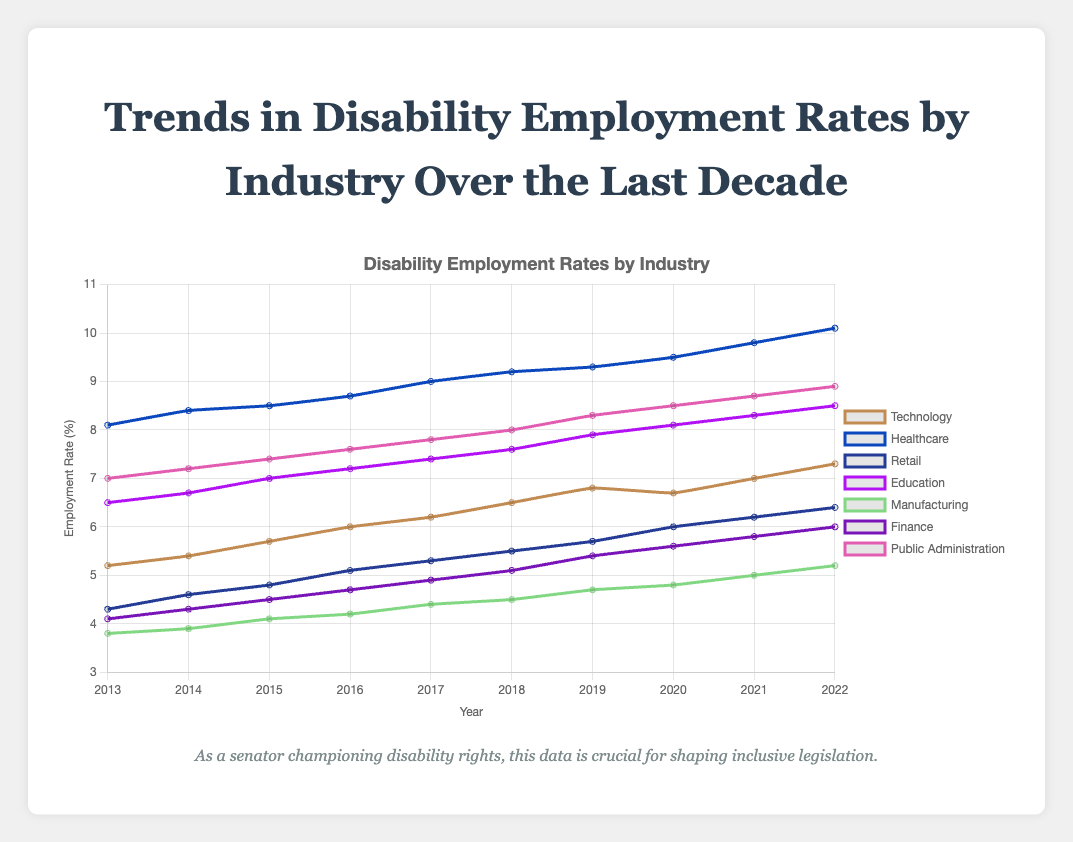What industry shows the highest increase in disability employment rates over the last decade? To find the industry with the highest increase, subtract the employment rate in 2013 from the employment rate in 2022 for each industry. Healthcare has an employment rate increase of 10.1 - 8.1 = 2.0, which is the highest among all industries.
Answer: Healthcare Which industry had the lowest disability employment rate in 2013, and what was the value in that year? Compare the employment rates of all industries in 2013. Manufacturing had the lowest employment rate in 2013 at 3.8%.
Answer: Manufacturing, 3.8% In which year did the Technology industry see a dip in disability employment rates? Look at the data trend for the Technology industry. There was a slight dip from 6.8% in 2019 to 6.7% in 2020.
Answer: 2020 How does the disability employment rate in the Education sector in 2022 compare to that in the Finance sector in the same year? Compare the employment rates in 2022 for both Education and Finance sectors. Education has a rate of 8.5%, while Finance has a rate of 6.0%. Education has a higher rate than Finance.
Answer: Education is higher What is the average disability employment rate for the Retail industry over the decade? Add all the annual rates of the Retail industry and divide by the number of years: (4.3 + 4.6 + 4.8 + 5.1 + 5.3 + 5.5 + 5.7 + 6.0 + 6.2 + 6.4) / 10 = 5.39%.
Answer: 5.39% Which industry had the most steady increase in employment rates over the decade? Compare the trends for each industry. Public Administration shows a steady and consistent increase from 7.0% in 2013 to 8.9% in 2022 without dips.
Answer: Public Administration Between 2018 and 2020, which industry witnessed the highest rise in disability employment rates? Subtract the 2018 rate from the 2020 rate for each industry. Healthcare increased from 9.2% to 9.5%, a rise of 0.3%.
Answer: Healthcare What is the combined disability employment rate of the Manufacturing and Public Administration sectors in 2022? Add the 2022 rates for Manufacturing (5.2%) and Public Administration (8.9%): 5.2 + 8.9 = 14.1%.
Answer: 14.1% How did the Finance industry's rate change from 2014 to 2019? Subtract the 2014 rate from the 2019 rate for the Finance industry: 5.4 - 4.3 = 1.1%. The rate increased by 1.1%.
Answer: Increased by 1.1% What is the difference in disability employment rates between the Healthcare and Retail industries in 2022? Subtract the 2022 employment rate in Retail (6.4%) from that in Healthcare (10.1%): 10.1 - 6.4 = 3.7%.
Answer: 3.7% 